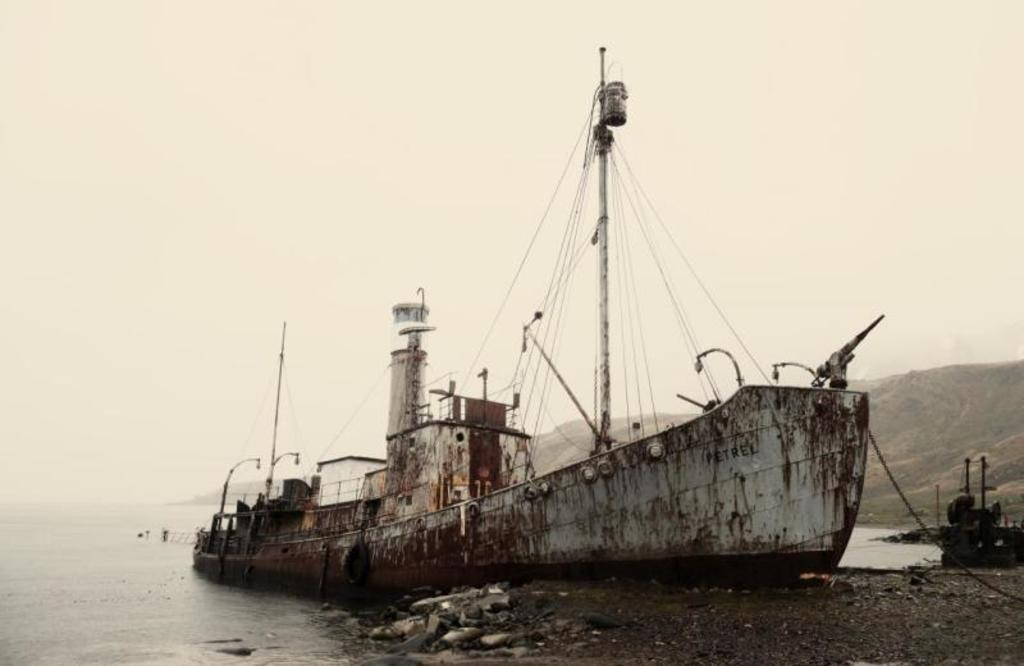What is located in the water in the image? There is a boat in the water in the image. What can be seen on the right side of the image? There is an object on the right side of the image. What type of natural landscape is visible in the background of the image? Mountains and the sky are visible in the background of the image. What type of pie is being served on the boat in the image? There is no pie present in the image; it features a boat in the water with an object on the right side and mountains and the sky in the background. 